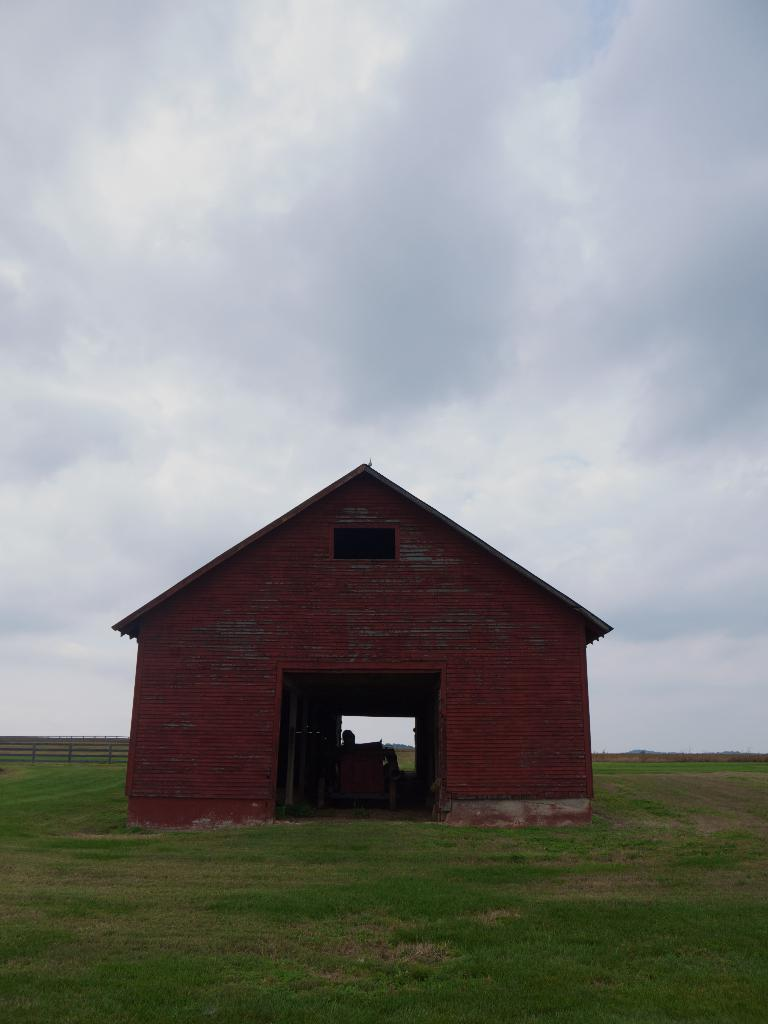What is the main structure in the middle of the image? There is a house in the middle of the image. What type of vegetation is at the bottom of the image? There is grass at the bottom of the image. What can be seen in the background of the image? There is a fence and the sky visible in the background of the image. What is the condition of the sky in the image? Clouds are present in the sky. What shape is the holiday depicted in the image? There is no holiday depicted in the image; it features a house, grass, a fence, and a cloudy sky. What type of grass is growing on the roof of the house in the image? There is no grass growing on the roof of the house in the image; it only has grass at the bottom. 